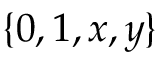Convert formula to latex. <formula><loc_0><loc_0><loc_500><loc_500>\{ 0 , 1 , x , y \}</formula> 